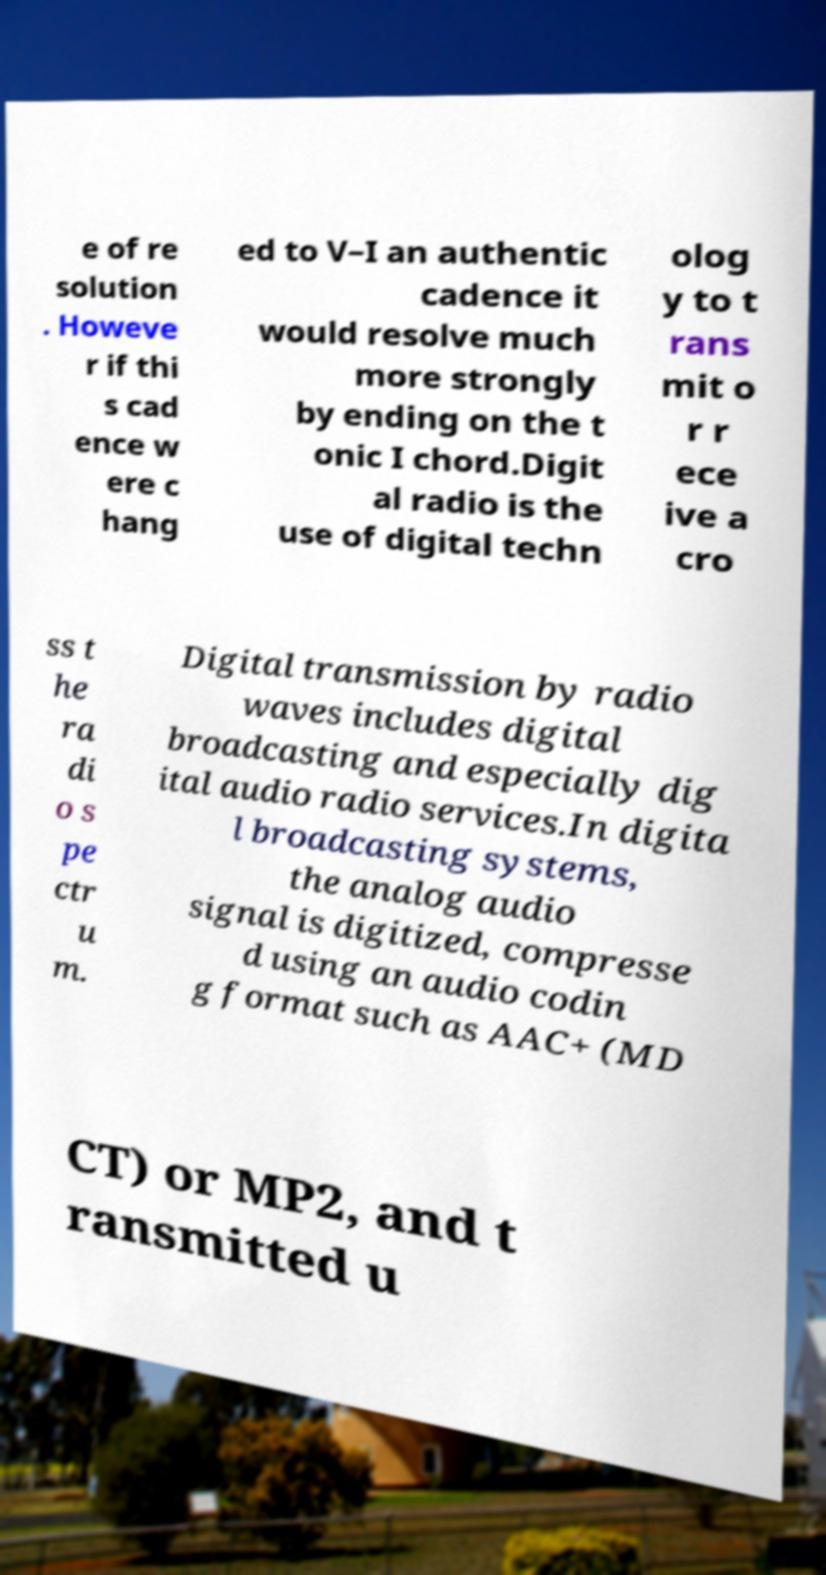Could you extract and type out the text from this image? e of re solution . Howeve r if thi s cad ence w ere c hang ed to V–I an authentic cadence it would resolve much more strongly by ending on the t onic I chord.Digit al radio is the use of digital techn olog y to t rans mit o r r ece ive a cro ss t he ra di o s pe ctr u m. Digital transmission by radio waves includes digital broadcasting and especially dig ital audio radio services.In digita l broadcasting systems, the analog audio signal is digitized, compresse d using an audio codin g format such as AAC+ (MD CT) or MP2, and t ransmitted u 